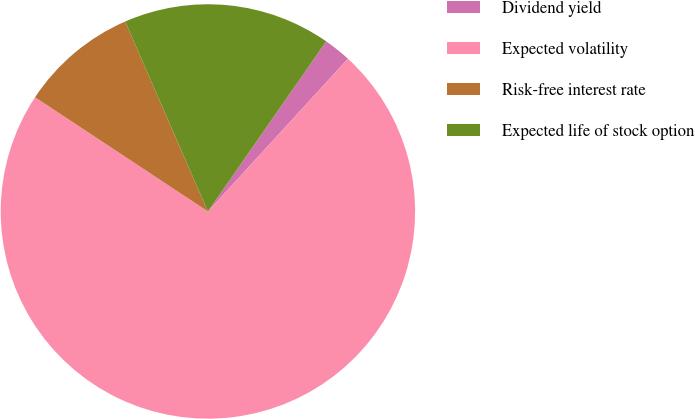Convert chart to OTSL. <chart><loc_0><loc_0><loc_500><loc_500><pie_chart><fcel>Dividend yield<fcel>Expected volatility<fcel>Risk-free interest rate<fcel>Expected life of stock option<nl><fcel>2.14%<fcel>72.48%<fcel>9.17%<fcel>16.21%<nl></chart> 